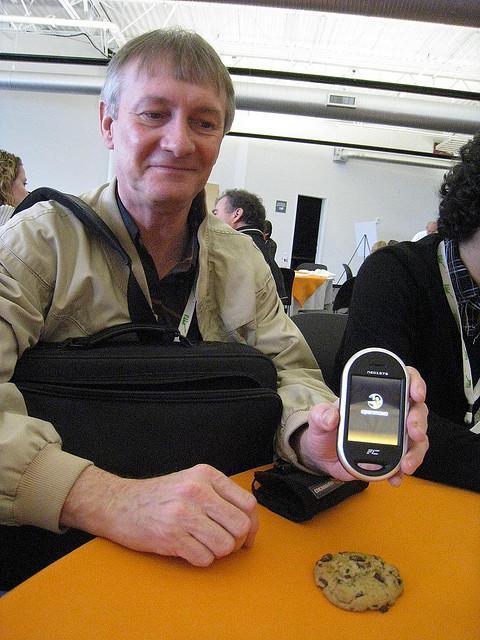How many people can you see?
Give a very brief answer. 3. 